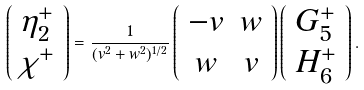<formula> <loc_0><loc_0><loc_500><loc_500>\left ( \begin{array} { c } \eta _ { 2 } ^ { + } \\ \chi ^ { + } \\ \end{array} \right ) = \frac { 1 } { ( v ^ { 2 } + w ^ { 2 } ) ^ { 1 / 2 } } \left ( \begin{array} { c c } - v & w \\ w & v \end{array} \right ) \left ( \begin{array} { c } G ^ { + } _ { 5 } \\ H ^ { + } _ { 6 } \end{array} \right ) .</formula> 